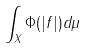<formula> <loc_0><loc_0><loc_500><loc_500>\int _ { X } \Phi ( | f | ) d \mu</formula> 